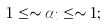<formula> <loc_0><loc_0><loc_500><loc_500>1 \leq \sim \alpha _ { i } \leq \sim 1 ;</formula> 